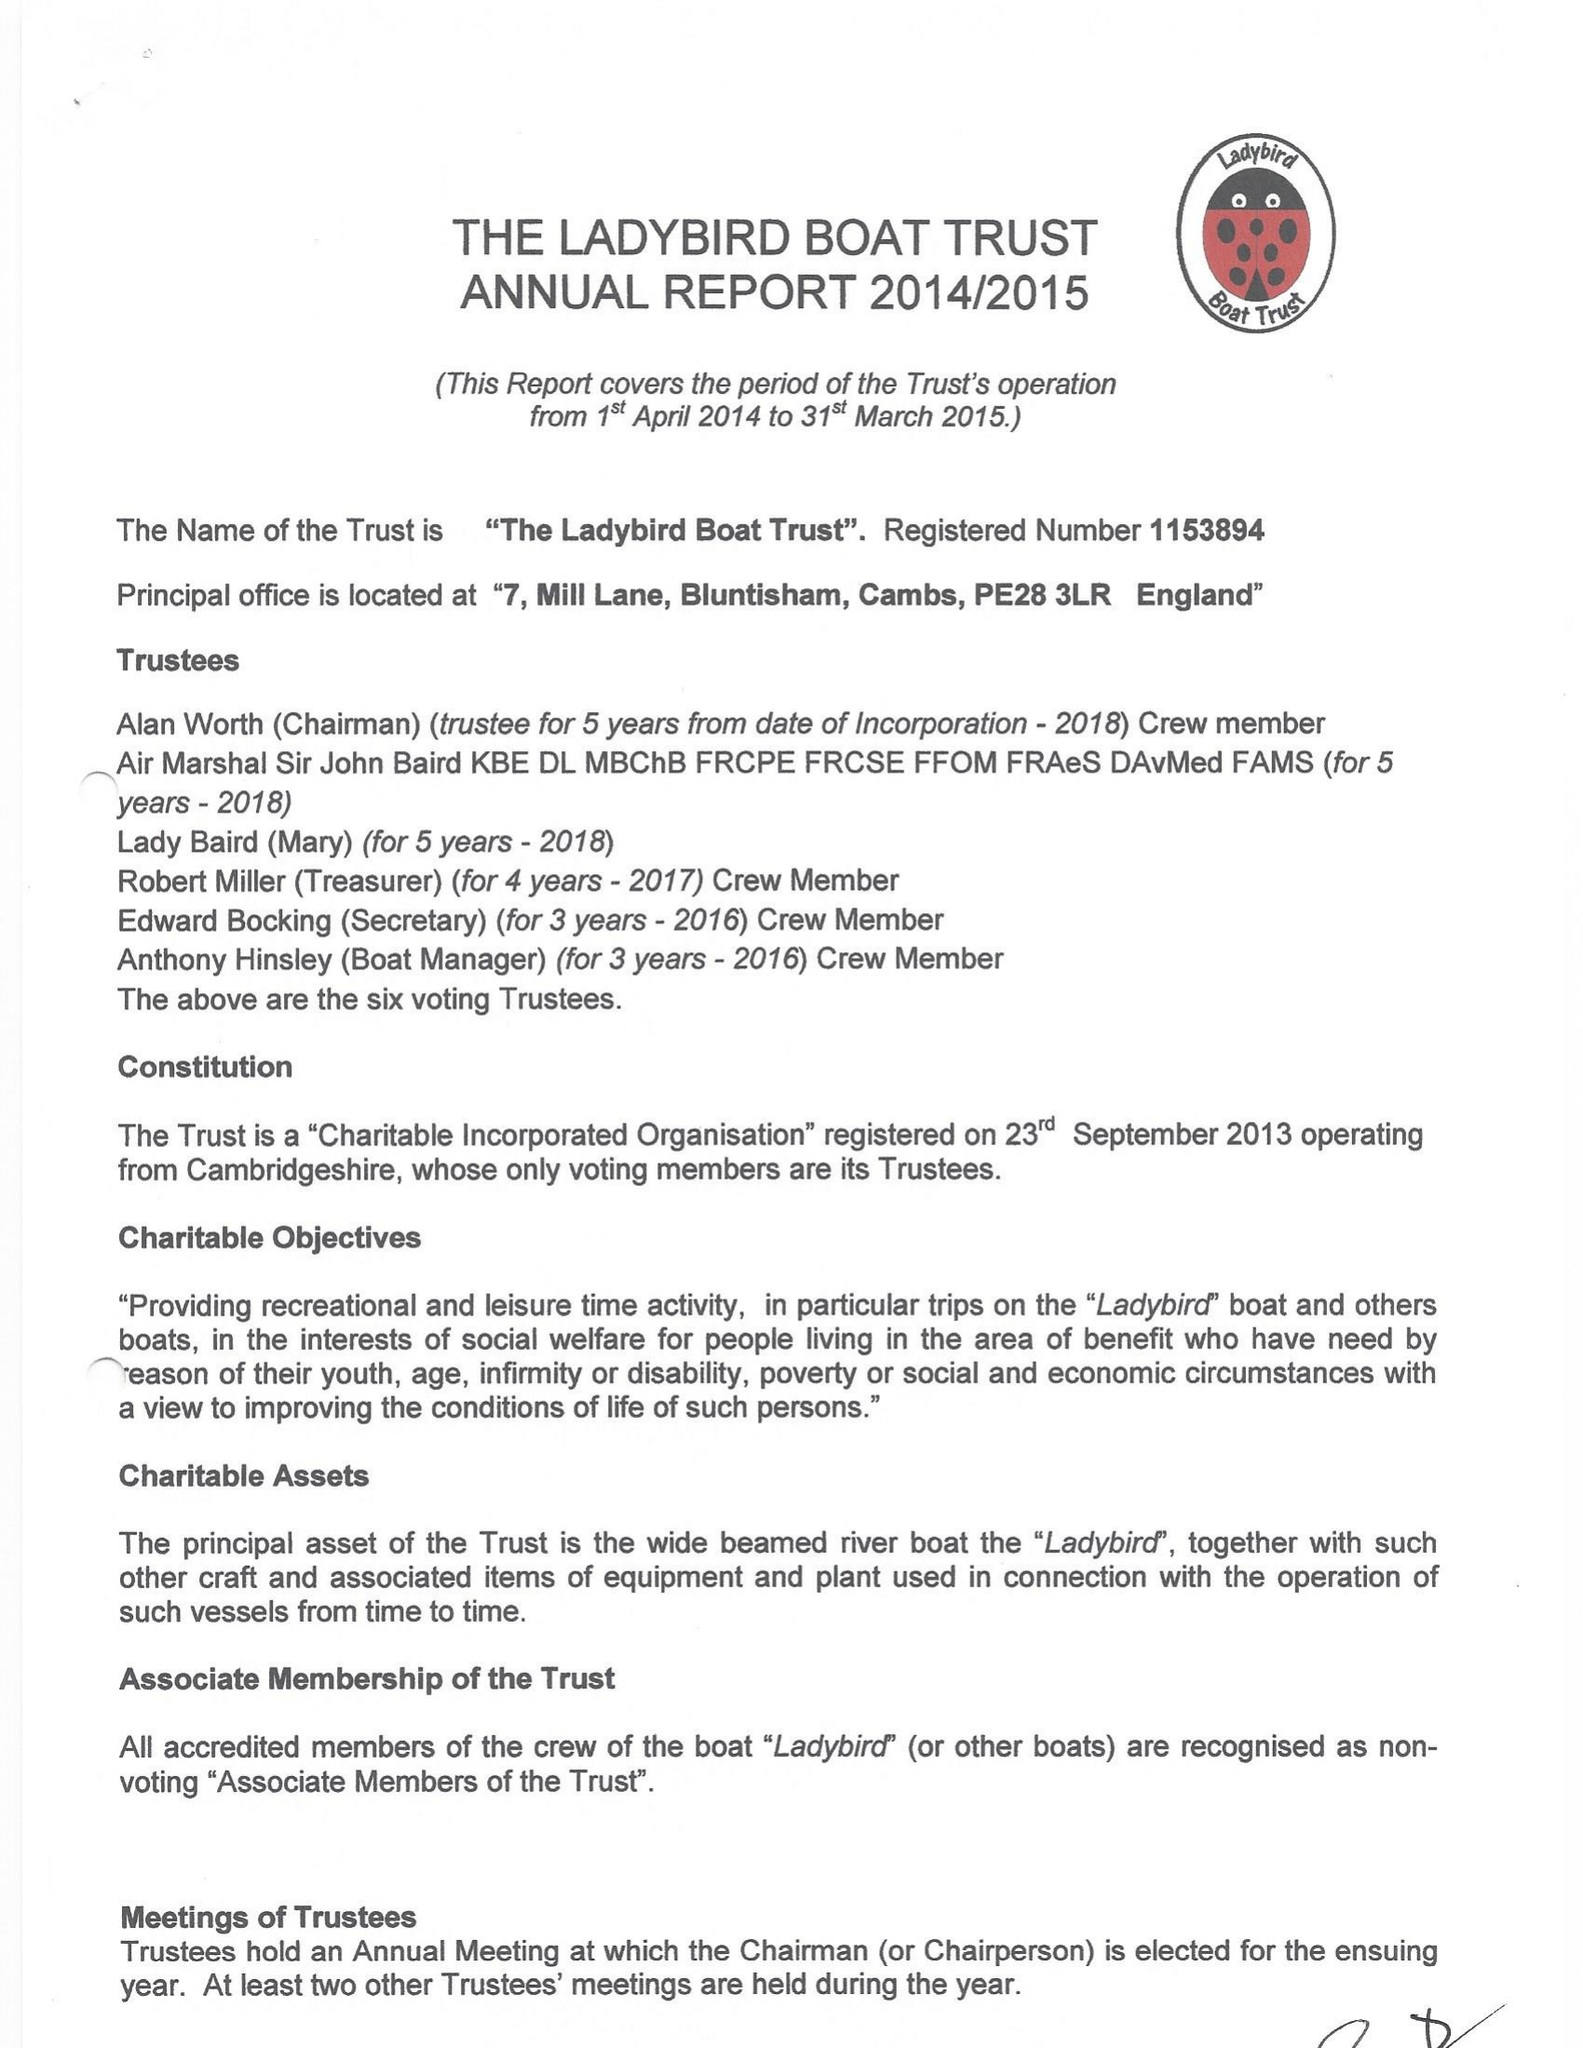What is the value for the charity_name?
Answer the question using a single word or phrase. The Ladybird Boat Trust 